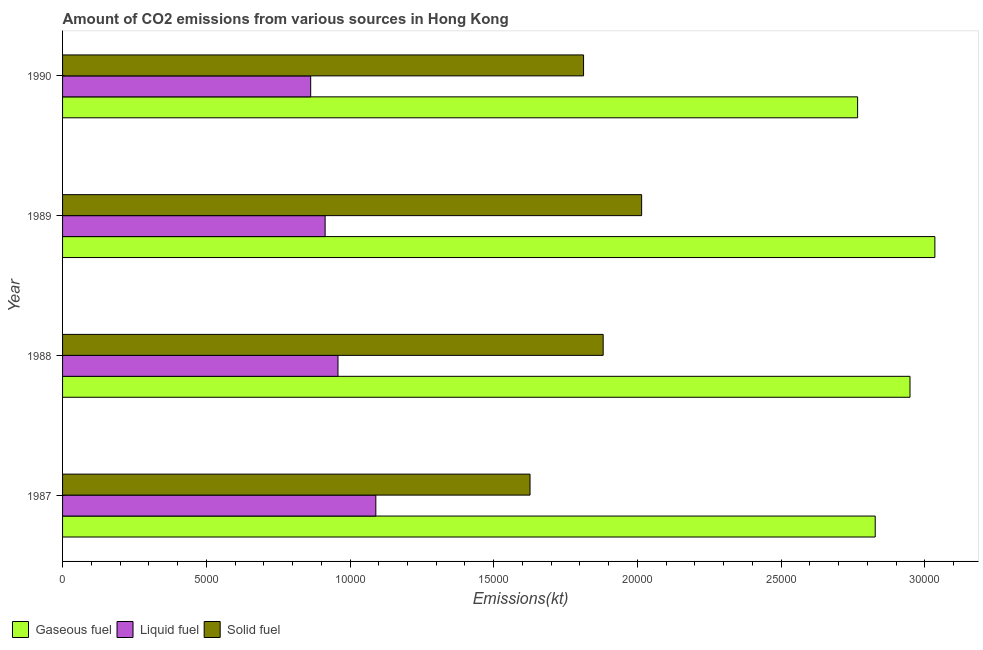How many groups of bars are there?
Keep it short and to the point. 4. Are the number of bars per tick equal to the number of legend labels?
Offer a very short reply. Yes. How many bars are there on the 4th tick from the top?
Provide a succinct answer. 3. In how many cases, is the number of bars for a given year not equal to the number of legend labels?
Offer a very short reply. 0. What is the amount of co2 emissions from solid fuel in 1988?
Provide a short and direct response. 1.88e+04. Across all years, what is the maximum amount of co2 emissions from liquid fuel?
Provide a short and direct response. 1.09e+04. Across all years, what is the minimum amount of co2 emissions from solid fuel?
Your response must be concise. 1.63e+04. What is the total amount of co2 emissions from liquid fuel in the graph?
Offer a terse response. 3.82e+04. What is the difference between the amount of co2 emissions from solid fuel in 1988 and that in 1990?
Your answer should be compact. 682.06. What is the difference between the amount of co2 emissions from gaseous fuel in 1990 and the amount of co2 emissions from solid fuel in 1989?
Offer a very short reply. 7513.68. What is the average amount of co2 emissions from gaseous fuel per year?
Ensure brevity in your answer.  2.89e+04. In the year 1989, what is the difference between the amount of co2 emissions from solid fuel and amount of co2 emissions from gaseous fuel?
Give a very brief answer. -1.02e+04. In how many years, is the amount of co2 emissions from liquid fuel greater than 19000 kt?
Ensure brevity in your answer.  0. What is the ratio of the amount of co2 emissions from liquid fuel in 1987 to that in 1988?
Ensure brevity in your answer.  1.14. What is the difference between the highest and the second highest amount of co2 emissions from solid fuel?
Ensure brevity in your answer.  1338.45. What is the difference between the highest and the lowest amount of co2 emissions from liquid fuel?
Provide a succinct answer. 2266.21. In how many years, is the amount of co2 emissions from liquid fuel greater than the average amount of co2 emissions from liquid fuel taken over all years?
Provide a short and direct response. 2. What does the 3rd bar from the top in 1987 represents?
Provide a succinct answer. Gaseous fuel. What does the 3rd bar from the bottom in 1988 represents?
Offer a very short reply. Solid fuel. Is it the case that in every year, the sum of the amount of co2 emissions from gaseous fuel and amount of co2 emissions from liquid fuel is greater than the amount of co2 emissions from solid fuel?
Give a very brief answer. Yes. What is the difference between two consecutive major ticks on the X-axis?
Offer a terse response. 5000. Are the values on the major ticks of X-axis written in scientific E-notation?
Give a very brief answer. No. Does the graph contain any zero values?
Provide a short and direct response. No. How many legend labels are there?
Your answer should be very brief. 3. What is the title of the graph?
Offer a terse response. Amount of CO2 emissions from various sources in Hong Kong. What is the label or title of the X-axis?
Provide a short and direct response. Emissions(kt). What is the Emissions(kt) in Gaseous fuel in 1987?
Give a very brief answer. 2.83e+04. What is the Emissions(kt) in Liquid fuel in 1987?
Make the answer very short. 1.09e+04. What is the Emissions(kt) of Solid fuel in 1987?
Provide a short and direct response. 1.63e+04. What is the Emissions(kt) of Gaseous fuel in 1988?
Provide a succinct answer. 2.95e+04. What is the Emissions(kt) of Liquid fuel in 1988?
Your answer should be very brief. 9581.87. What is the Emissions(kt) of Solid fuel in 1988?
Your answer should be compact. 1.88e+04. What is the Emissions(kt) in Gaseous fuel in 1989?
Give a very brief answer. 3.03e+04. What is the Emissions(kt) in Liquid fuel in 1989?
Offer a very short reply. 9134.5. What is the Emissions(kt) of Solid fuel in 1989?
Give a very brief answer. 2.01e+04. What is the Emissions(kt) in Gaseous fuel in 1990?
Your response must be concise. 2.77e+04. What is the Emissions(kt) in Liquid fuel in 1990?
Your response must be concise. 8632.12. What is the Emissions(kt) in Solid fuel in 1990?
Ensure brevity in your answer.  1.81e+04. Across all years, what is the maximum Emissions(kt) of Gaseous fuel?
Keep it short and to the point. 3.03e+04. Across all years, what is the maximum Emissions(kt) of Liquid fuel?
Offer a very short reply. 1.09e+04. Across all years, what is the maximum Emissions(kt) of Solid fuel?
Provide a succinct answer. 2.01e+04. Across all years, what is the minimum Emissions(kt) of Gaseous fuel?
Ensure brevity in your answer.  2.77e+04. Across all years, what is the minimum Emissions(kt) of Liquid fuel?
Offer a very short reply. 8632.12. Across all years, what is the minimum Emissions(kt) of Solid fuel?
Your answer should be compact. 1.63e+04. What is the total Emissions(kt) in Gaseous fuel in the graph?
Make the answer very short. 1.16e+05. What is the total Emissions(kt) in Liquid fuel in the graph?
Give a very brief answer. 3.82e+04. What is the total Emissions(kt) of Solid fuel in the graph?
Offer a terse response. 7.33e+04. What is the difference between the Emissions(kt) of Gaseous fuel in 1987 and that in 1988?
Offer a very short reply. -1210.11. What is the difference between the Emissions(kt) in Liquid fuel in 1987 and that in 1988?
Your response must be concise. 1316.45. What is the difference between the Emissions(kt) of Solid fuel in 1987 and that in 1988?
Offer a terse response. -2544.9. What is the difference between the Emissions(kt) of Gaseous fuel in 1987 and that in 1989?
Provide a short and direct response. -2075.52. What is the difference between the Emissions(kt) of Liquid fuel in 1987 and that in 1989?
Your answer should be compact. 1763.83. What is the difference between the Emissions(kt) of Solid fuel in 1987 and that in 1989?
Offer a very short reply. -3883.35. What is the difference between the Emissions(kt) in Gaseous fuel in 1987 and that in 1990?
Provide a succinct answer. 612.39. What is the difference between the Emissions(kt) of Liquid fuel in 1987 and that in 1990?
Keep it short and to the point. 2266.21. What is the difference between the Emissions(kt) of Solid fuel in 1987 and that in 1990?
Your answer should be very brief. -1862.84. What is the difference between the Emissions(kt) of Gaseous fuel in 1988 and that in 1989?
Provide a short and direct response. -865.41. What is the difference between the Emissions(kt) of Liquid fuel in 1988 and that in 1989?
Provide a succinct answer. 447.37. What is the difference between the Emissions(kt) in Solid fuel in 1988 and that in 1989?
Your answer should be very brief. -1338.45. What is the difference between the Emissions(kt) in Gaseous fuel in 1988 and that in 1990?
Make the answer very short. 1822.5. What is the difference between the Emissions(kt) in Liquid fuel in 1988 and that in 1990?
Ensure brevity in your answer.  949.75. What is the difference between the Emissions(kt) in Solid fuel in 1988 and that in 1990?
Keep it short and to the point. 682.06. What is the difference between the Emissions(kt) of Gaseous fuel in 1989 and that in 1990?
Offer a very short reply. 2687.91. What is the difference between the Emissions(kt) of Liquid fuel in 1989 and that in 1990?
Offer a very short reply. 502.38. What is the difference between the Emissions(kt) in Solid fuel in 1989 and that in 1990?
Your response must be concise. 2020.52. What is the difference between the Emissions(kt) of Gaseous fuel in 1987 and the Emissions(kt) of Liquid fuel in 1988?
Your answer should be compact. 1.87e+04. What is the difference between the Emissions(kt) of Gaseous fuel in 1987 and the Emissions(kt) of Solid fuel in 1988?
Your response must be concise. 9464.53. What is the difference between the Emissions(kt) of Liquid fuel in 1987 and the Emissions(kt) of Solid fuel in 1988?
Keep it short and to the point. -7909.72. What is the difference between the Emissions(kt) of Gaseous fuel in 1987 and the Emissions(kt) of Liquid fuel in 1989?
Provide a succinct answer. 1.91e+04. What is the difference between the Emissions(kt) in Gaseous fuel in 1987 and the Emissions(kt) in Solid fuel in 1989?
Provide a succinct answer. 8126.07. What is the difference between the Emissions(kt) of Liquid fuel in 1987 and the Emissions(kt) of Solid fuel in 1989?
Provide a short and direct response. -9248.17. What is the difference between the Emissions(kt) in Gaseous fuel in 1987 and the Emissions(kt) in Liquid fuel in 1990?
Make the answer very short. 1.96e+04. What is the difference between the Emissions(kt) in Gaseous fuel in 1987 and the Emissions(kt) in Solid fuel in 1990?
Offer a terse response. 1.01e+04. What is the difference between the Emissions(kt) of Liquid fuel in 1987 and the Emissions(kt) of Solid fuel in 1990?
Ensure brevity in your answer.  -7227.66. What is the difference between the Emissions(kt) in Gaseous fuel in 1988 and the Emissions(kt) in Liquid fuel in 1989?
Offer a terse response. 2.03e+04. What is the difference between the Emissions(kt) in Gaseous fuel in 1988 and the Emissions(kt) in Solid fuel in 1989?
Provide a succinct answer. 9336.18. What is the difference between the Emissions(kt) in Liquid fuel in 1988 and the Emissions(kt) in Solid fuel in 1989?
Give a very brief answer. -1.06e+04. What is the difference between the Emissions(kt) of Gaseous fuel in 1988 and the Emissions(kt) of Liquid fuel in 1990?
Ensure brevity in your answer.  2.09e+04. What is the difference between the Emissions(kt) of Gaseous fuel in 1988 and the Emissions(kt) of Solid fuel in 1990?
Your response must be concise. 1.14e+04. What is the difference between the Emissions(kt) of Liquid fuel in 1988 and the Emissions(kt) of Solid fuel in 1990?
Your answer should be very brief. -8544.11. What is the difference between the Emissions(kt) of Gaseous fuel in 1989 and the Emissions(kt) of Liquid fuel in 1990?
Provide a succinct answer. 2.17e+04. What is the difference between the Emissions(kt) of Gaseous fuel in 1989 and the Emissions(kt) of Solid fuel in 1990?
Provide a succinct answer. 1.22e+04. What is the difference between the Emissions(kt) of Liquid fuel in 1989 and the Emissions(kt) of Solid fuel in 1990?
Keep it short and to the point. -8991.48. What is the average Emissions(kt) of Gaseous fuel per year?
Your answer should be compact. 2.89e+04. What is the average Emissions(kt) in Liquid fuel per year?
Give a very brief answer. 9561.7. What is the average Emissions(kt) of Solid fuel per year?
Provide a succinct answer. 1.83e+04. In the year 1987, what is the difference between the Emissions(kt) in Gaseous fuel and Emissions(kt) in Liquid fuel?
Your answer should be very brief. 1.74e+04. In the year 1987, what is the difference between the Emissions(kt) in Gaseous fuel and Emissions(kt) in Solid fuel?
Make the answer very short. 1.20e+04. In the year 1987, what is the difference between the Emissions(kt) in Liquid fuel and Emissions(kt) in Solid fuel?
Offer a very short reply. -5364.82. In the year 1988, what is the difference between the Emissions(kt) in Gaseous fuel and Emissions(kt) in Liquid fuel?
Offer a terse response. 1.99e+04. In the year 1988, what is the difference between the Emissions(kt) in Gaseous fuel and Emissions(kt) in Solid fuel?
Your answer should be compact. 1.07e+04. In the year 1988, what is the difference between the Emissions(kt) of Liquid fuel and Emissions(kt) of Solid fuel?
Your response must be concise. -9226.17. In the year 1989, what is the difference between the Emissions(kt) in Gaseous fuel and Emissions(kt) in Liquid fuel?
Provide a succinct answer. 2.12e+04. In the year 1989, what is the difference between the Emissions(kt) in Gaseous fuel and Emissions(kt) in Solid fuel?
Your answer should be compact. 1.02e+04. In the year 1989, what is the difference between the Emissions(kt) of Liquid fuel and Emissions(kt) of Solid fuel?
Keep it short and to the point. -1.10e+04. In the year 1990, what is the difference between the Emissions(kt) in Gaseous fuel and Emissions(kt) in Liquid fuel?
Offer a terse response. 1.90e+04. In the year 1990, what is the difference between the Emissions(kt) of Gaseous fuel and Emissions(kt) of Solid fuel?
Provide a short and direct response. 9534.2. In the year 1990, what is the difference between the Emissions(kt) of Liquid fuel and Emissions(kt) of Solid fuel?
Ensure brevity in your answer.  -9493.86. What is the ratio of the Emissions(kt) in Liquid fuel in 1987 to that in 1988?
Give a very brief answer. 1.14. What is the ratio of the Emissions(kt) of Solid fuel in 1987 to that in 1988?
Provide a short and direct response. 0.86. What is the ratio of the Emissions(kt) in Gaseous fuel in 1987 to that in 1989?
Your answer should be very brief. 0.93. What is the ratio of the Emissions(kt) of Liquid fuel in 1987 to that in 1989?
Your answer should be very brief. 1.19. What is the ratio of the Emissions(kt) of Solid fuel in 1987 to that in 1989?
Your answer should be very brief. 0.81. What is the ratio of the Emissions(kt) in Gaseous fuel in 1987 to that in 1990?
Make the answer very short. 1.02. What is the ratio of the Emissions(kt) of Liquid fuel in 1987 to that in 1990?
Keep it short and to the point. 1.26. What is the ratio of the Emissions(kt) of Solid fuel in 1987 to that in 1990?
Your answer should be very brief. 0.9. What is the ratio of the Emissions(kt) of Gaseous fuel in 1988 to that in 1989?
Your answer should be very brief. 0.97. What is the ratio of the Emissions(kt) in Liquid fuel in 1988 to that in 1989?
Your answer should be very brief. 1.05. What is the ratio of the Emissions(kt) of Solid fuel in 1988 to that in 1989?
Offer a very short reply. 0.93. What is the ratio of the Emissions(kt) of Gaseous fuel in 1988 to that in 1990?
Give a very brief answer. 1.07. What is the ratio of the Emissions(kt) in Liquid fuel in 1988 to that in 1990?
Your response must be concise. 1.11. What is the ratio of the Emissions(kt) of Solid fuel in 1988 to that in 1990?
Provide a succinct answer. 1.04. What is the ratio of the Emissions(kt) in Gaseous fuel in 1989 to that in 1990?
Provide a short and direct response. 1.1. What is the ratio of the Emissions(kt) in Liquid fuel in 1989 to that in 1990?
Provide a short and direct response. 1.06. What is the ratio of the Emissions(kt) of Solid fuel in 1989 to that in 1990?
Ensure brevity in your answer.  1.11. What is the difference between the highest and the second highest Emissions(kt) of Gaseous fuel?
Offer a terse response. 865.41. What is the difference between the highest and the second highest Emissions(kt) in Liquid fuel?
Your answer should be very brief. 1316.45. What is the difference between the highest and the second highest Emissions(kt) in Solid fuel?
Offer a very short reply. 1338.45. What is the difference between the highest and the lowest Emissions(kt) of Gaseous fuel?
Ensure brevity in your answer.  2687.91. What is the difference between the highest and the lowest Emissions(kt) of Liquid fuel?
Your answer should be very brief. 2266.21. What is the difference between the highest and the lowest Emissions(kt) in Solid fuel?
Give a very brief answer. 3883.35. 